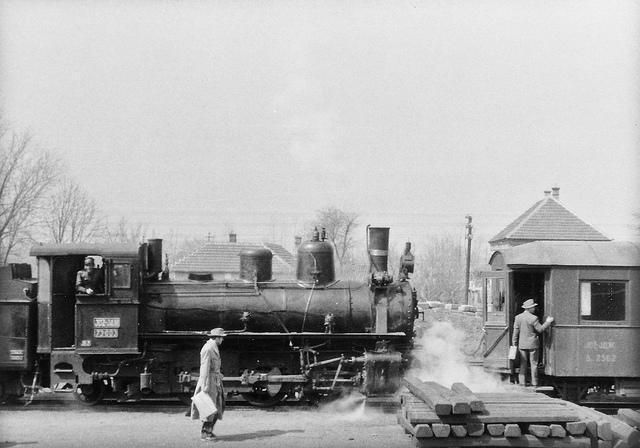How many people are there?
Give a very brief answer. 3. 